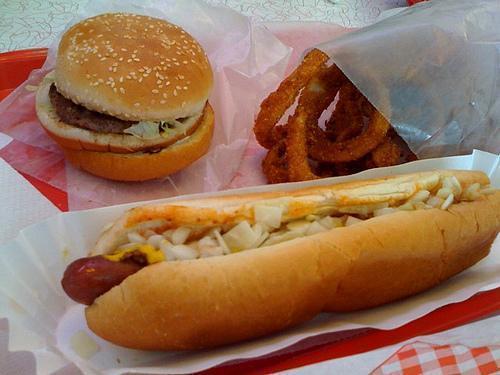Where could you get this food?
Select the accurate answer and provide explanation: 'Answer: answer
Rationale: rationale.'
Options: Fruit vendor, taco truck, starbucks, burger joint. Answer: burger joint.
Rationale: Hot dogs and burgers are shown. 